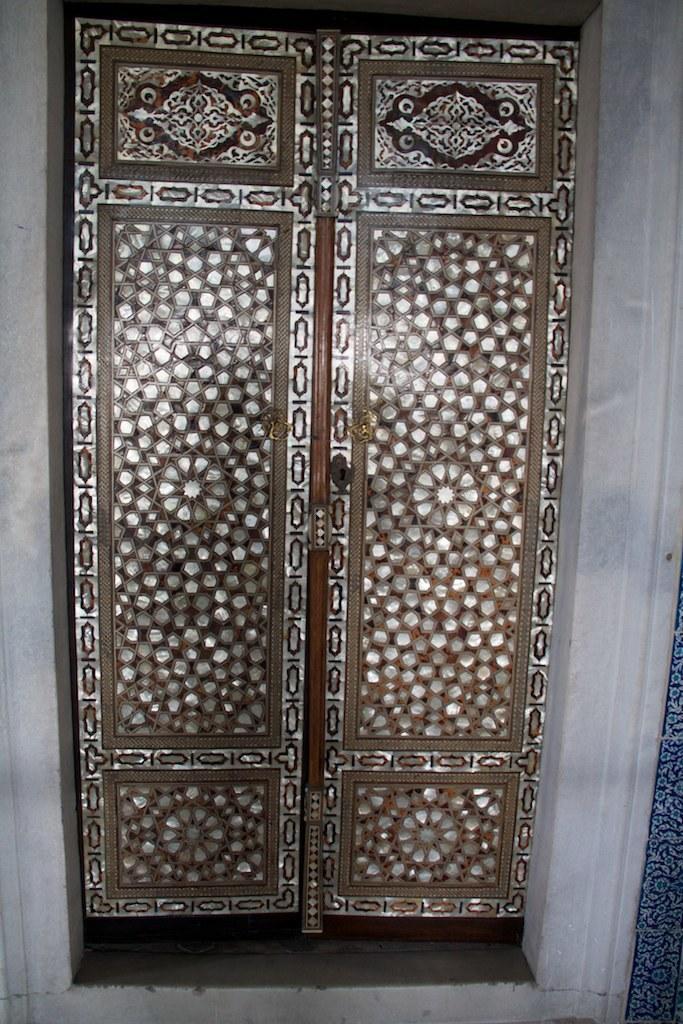Please provide a concise description of this image. In this image we can see doors and wall. On the right side there is an object. 